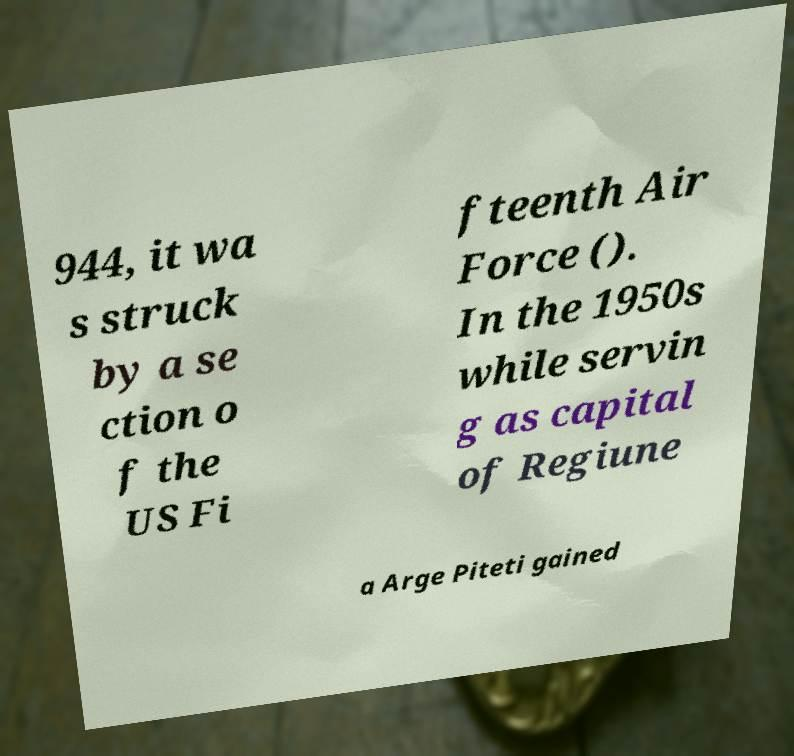Can you read and provide the text displayed in the image?This photo seems to have some interesting text. Can you extract and type it out for me? 944, it wa s struck by a se ction o f the US Fi fteenth Air Force (). In the 1950s while servin g as capital of Regiune a Arge Piteti gained 